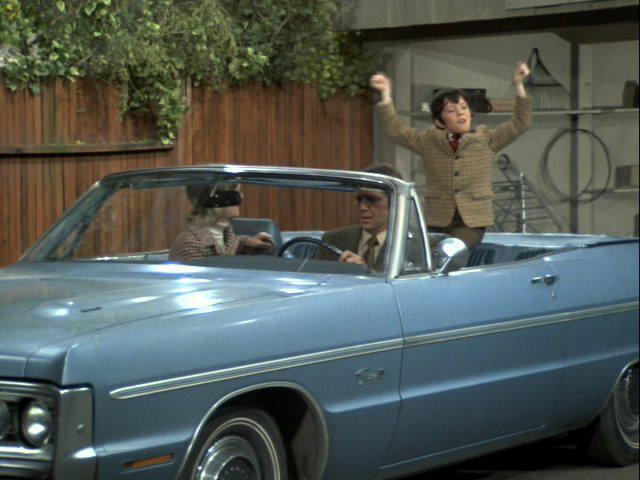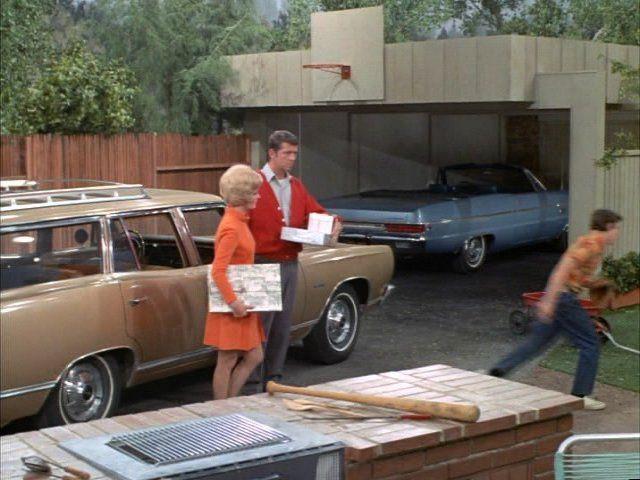The first image is the image on the left, the second image is the image on the right. Evaluate the accuracy of this statement regarding the images: "An image shows a man sitting behind the wheel of a light blue convertible in front of an open garage.". Is it true? Answer yes or no. Yes. The first image is the image on the left, the second image is the image on the right. For the images shown, is this caption "No one is sitting in the car in the image on the left." true? Answer yes or no. No. 